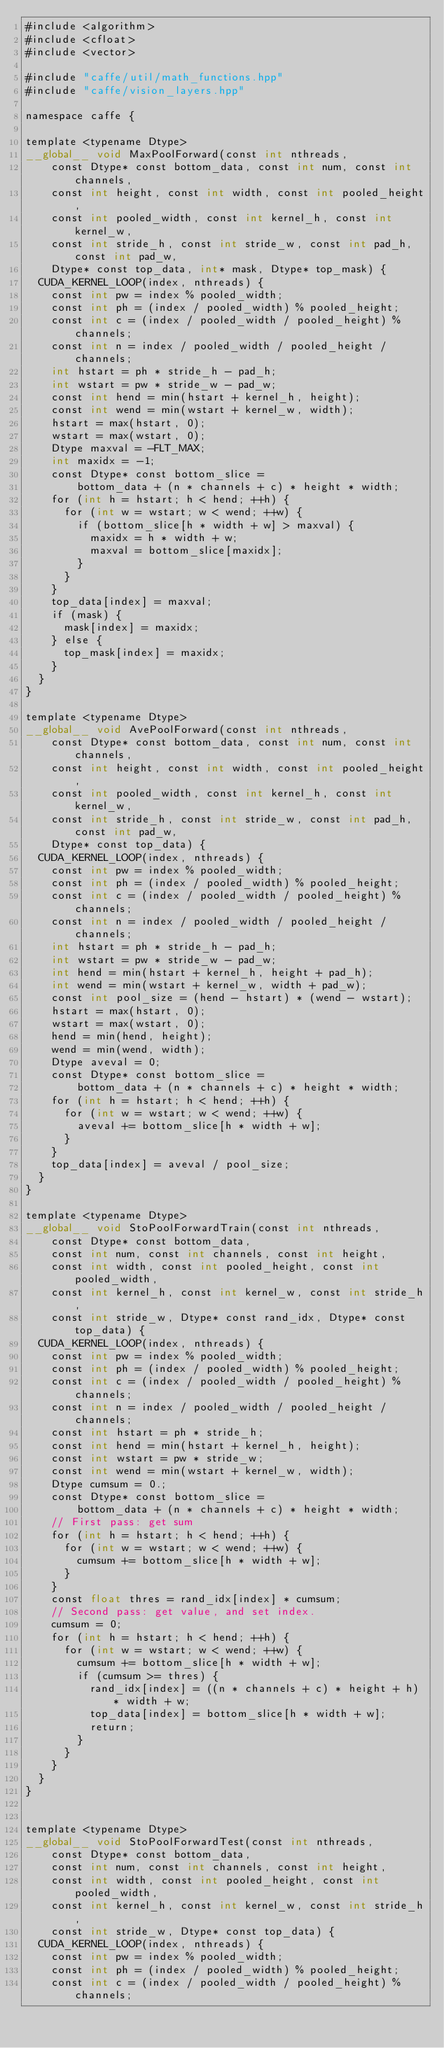Convert code to text. <code><loc_0><loc_0><loc_500><loc_500><_Cuda_>#include <algorithm>
#include <cfloat>
#include <vector>

#include "caffe/util/math_functions.hpp"
#include "caffe/vision_layers.hpp"

namespace caffe {

template <typename Dtype>
__global__ void MaxPoolForward(const int nthreads,
    const Dtype* const bottom_data, const int num, const int channels,
    const int height, const int width, const int pooled_height,
    const int pooled_width, const int kernel_h, const int kernel_w,
    const int stride_h, const int stride_w, const int pad_h, const int pad_w,
    Dtype* const top_data, int* mask, Dtype* top_mask) {
  CUDA_KERNEL_LOOP(index, nthreads) {
    const int pw = index % pooled_width;
    const int ph = (index / pooled_width) % pooled_height;
    const int c = (index / pooled_width / pooled_height) % channels;
    const int n = index / pooled_width / pooled_height / channels;
    int hstart = ph * stride_h - pad_h;
    int wstart = pw * stride_w - pad_w;
    const int hend = min(hstart + kernel_h, height);
    const int wend = min(wstart + kernel_w, width);
    hstart = max(hstart, 0);
    wstart = max(wstart, 0);
    Dtype maxval = -FLT_MAX;
    int maxidx = -1;
    const Dtype* const bottom_slice =
        bottom_data + (n * channels + c) * height * width;
    for (int h = hstart; h < hend; ++h) {
      for (int w = wstart; w < wend; ++w) {
        if (bottom_slice[h * width + w] > maxval) {
          maxidx = h * width + w;
          maxval = bottom_slice[maxidx];
        }
      }
    }
    top_data[index] = maxval;
    if (mask) {
      mask[index] = maxidx;
    } else {
      top_mask[index] = maxidx;
    }
  }
}

template <typename Dtype>
__global__ void AvePoolForward(const int nthreads,
    const Dtype* const bottom_data, const int num, const int channels,
    const int height, const int width, const int pooled_height,
    const int pooled_width, const int kernel_h, const int kernel_w,
    const int stride_h, const int stride_w, const int pad_h, const int pad_w,
    Dtype* const top_data) {
  CUDA_KERNEL_LOOP(index, nthreads) {
    const int pw = index % pooled_width;
    const int ph = (index / pooled_width) % pooled_height;
    const int c = (index / pooled_width / pooled_height) % channels;
    const int n = index / pooled_width / pooled_height / channels;
    int hstart = ph * stride_h - pad_h;
    int wstart = pw * stride_w - pad_w;
    int hend = min(hstart + kernel_h, height + pad_h);
    int wend = min(wstart + kernel_w, width + pad_w);
    const int pool_size = (hend - hstart) * (wend - wstart);
    hstart = max(hstart, 0);
    wstart = max(wstart, 0);
    hend = min(hend, height);
    wend = min(wend, width);
    Dtype aveval = 0;
    const Dtype* const bottom_slice =
        bottom_data + (n * channels + c) * height * width;
    for (int h = hstart; h < hend; ++h) {
      for (int w = wstart; w < wend; ++w) {
        aveval += bottom_slice[h * width + w];
      }
    }
    top_data[index] = aveval / pool_size;
  }
}

template <typename Dtype>
__global__ void StoPoolForwardTrain(const int nthreads,
    const Dtype* const bottom_data,
    const int num, const int channels, const int height,
    const int width, const int pooled_height, const int pooled_width,
    const int kernel_h, const int kernel_w, const int stride_h,
    const int stride_w, Dtype* const rand_idx, Dtype* const top_data) {
  CUDA_KERNEL_LOOP(index, nthreads) {
    const int pw = index % pooled_width;
    const int ph = (index / pooled_width) % pooled_height;
    const int c = (index / pooled_width / pooled_height) % channels;
    const int n = index / pooled_width / pooled_height / channels;
    const int hstart = ph * stride_h;
    const int hend = min(hstart + kernel_h, height);
    const int wstart = pw * stride_w;
    const int wend = min(wstart + kernel_w, width);
    Dtype cumsum = 0.;
    const Dtype* const bottom_slice =
        bottom_data + (n * channels + c) * height * width;
    // First pass: get sum
    for (int h = hstart; h < hend; ++h) {
      for (int w = wstart; w < wend; ++w) {
        cumsum += bottom_slice[h * width + w];
      }
    }
    const float thres = rand_idx[index] * cumsum;
    // Second pass: get value, and set index.
    cumsum = 0;
    for (int h = hstart; h < hend; ++h) {
      for (int w = wstart; w < wend; ++w) {
        cumsum += bottom_slice[h * width + w];
        if (cumsum >= thres) {
          rand_idx[index] = ((n * channels + c) * height + h) * width + w;
          top_data[index] = bottom_slice[h * width + w];
          return;
        }
      }
    }
  }
}


template <typename Dtype>
__global__ void StoPoolForwardTest(const int nthreads,
    const Dtype* const bottom_data,
    const int num, const int channels, const int height,
    const int width, const int pooled_height, const int pooled_width,
    const int kernel_h, const int kernel_w, const int stride_h,
    const int stride_w, Dtype* const top_data) {
  CUDA_KERNEL_LOOP(index, nthreads) {
    const int pw = index % pooled_width;
    const int ph = (index / pooled_width) % pooled_height;
    const int c = (index / pooled_width / pooled_height) % channels;</code> 